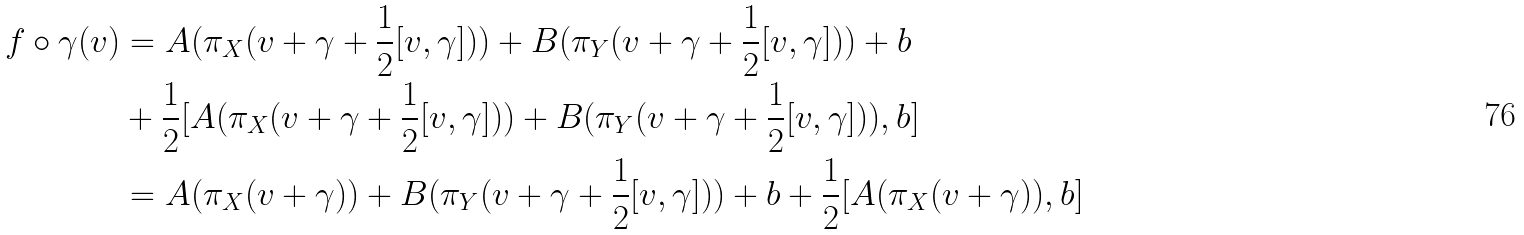Convert formula to latex. <formula><loc_0><loc_0><loc_500><loc_500>f \circ \gamma ( v ) & = A ( \pi _ { X } ( v + \gamma + \frac { 1 } { 2 } [ v , \gamma ] ) ) + B ( \pi _ { Y } ( v + \gamma + \frac { 1 } { 2 } [ v , \gamma ] ) ) + b \\ & + \frac { 1 } { 2 } [ A ( \pi _ { X } ( v + \gamma + \frac { 1 } { 2 } [ v , \gamma ] ) ) + B ( \pi _ { Y } ( v + \gamma + \frac { 1 } { 2 } [ v , \gamma ] ) ) , b ] \\ & = A ( \pi _ { X } ( v + \gamma ) ) + B ( \pi _ { Y } ( v + \gamma + \frac { 1 } { 2 } [ v , \gamma ] ) ) + b + \frac { 1 } { 2 } [ A ( \pi _ { X } ( v + \gamma ) ) , b ]</formula> 